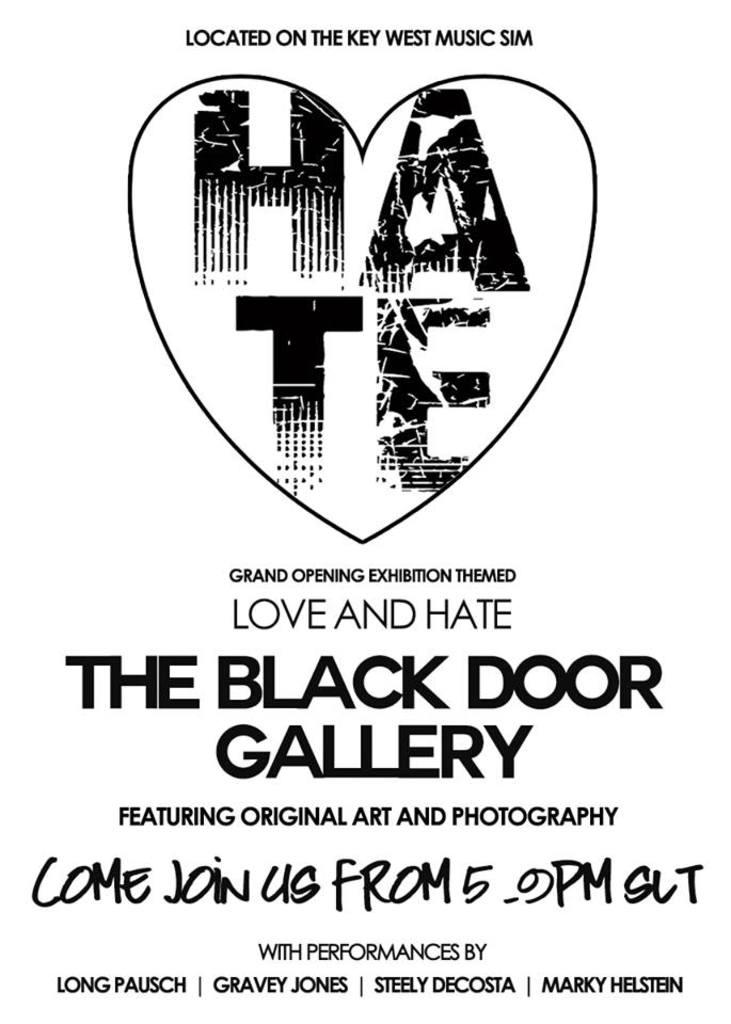What is the name of the gallery?
Your response must be concise. The black door gallery. What time does the event start?
Your response must be concise. 5 pm. 